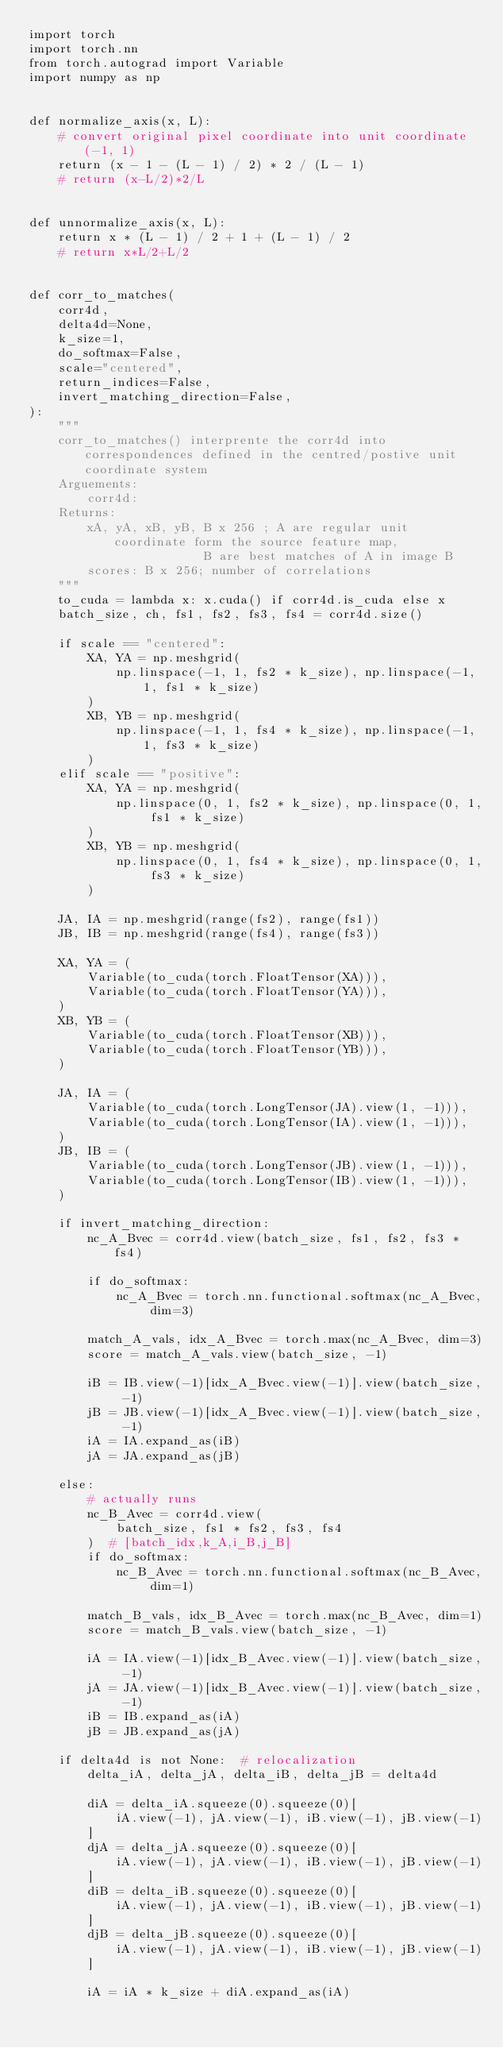Convert code to text. <code><loc_0><loc_0><loc_500><loc_500><_Python_>import torch
import torch.nn
from torch.autograd import Variable
import numpy as np


def normalize_axis(x, L):
    # convert original pixel coordinate into unit coordinate (-1, 1)
    return (x - 1 - (L - 1) / 2) * 2 / (L - 1)
    # return (x-L/2)*2/L


def unnormalize_axis(x, L):
    return x * (L - 1) / 2 + 1 + (L - 1) / 2
    # return x*L/2+L/2


def corr_to_matches(
    corr4d,
    delta4d=None,
    k_size=1,
    do_softmax=False,
    scale="centered",
    return_indices=False,
    invert_matching_direction=False,
):
    """
    corr_to_matches() interprente the corr4d into correspondences defined in the centred/postive unit coordinate system
    Arguements:
        corr4d:
    Returns:
        xA, yA, xB, yB, B x 256 ; A are regular unit coordinate form the source feature map, 
                        B are best matches of A in image B
        scores: B x 256; number of correlations
    """
    to_cuda = lambda x: x.cuda() if corr4d.is_cuda else x
    batch_size, ch, fs1, fs2, fs3, fs4 = corr4d.size()

    if scale == "centered":
        XA, YA = np.meshgrid(
            np.linspace(-1, 1, fs2 * k_size), np.linspace(-1, 1, fs1 * k_size)
        )
        XB, YB = np.meshgrid(
            np.linspace(-1, 1, fs4 * k_size), np.linspace(-1, 1, fs3 * k_size)
        )
    elif scale == "positive":
        XA, YA = np.meshgrid(
            np.linspace(0, 1, fs2 * k_size), np.linspace(0, 1, fs1 * k_size)
        )
        XB, YB = np.meshgrid(
            np.linspace(0, 1, fs4 * k_size), np.linspace(0, 1, fs3 * k_size)
        )

    JA, IA = np.meshgrid(range(fs2), range(fs1))
    JB, IB = np.meshgrid(range(fs4), range(fs3))

    XA, YA = (
        Variable(to_cuda(torch.FloatTensor(XA))),
        Variable(to_cuda(torch.FloatTensor(YA))),
    )
    XB, YB = (
        Variable(to_cuda(torch.FloatTensor(XB))),
        Variable(to_cuda(torch.FloatTensor(YB))),
    )

    JA, IA = (
        Variable(to_cuda(torch.LongTensor(JA).view(1, -1))),
        Variable(to_cuda(torch.LongTensor(IA).view(1, -1))),
    )
    JB, IB = (
        Variable(to_cuda(torch.LongTensor(JB).view(1, -1))),
        Variable(to_cuda(torch.LongTensor(IB).view(1, -1))),
    )

    if invert_matching_direction:
        nc_A_Bvec = corr4d.view(batch_size, fs1, fs2, fs3 * fs4)

        if do_softmax:
            nc_A_Bvec = torch.nn.functional.softmax(nc_A_Bvec, dim=3)

        match_A_vals, idx_A_Bvec = torch.max(nc_A_Bvec, dim=3)
        score = match_A_vals.view(batch_size, -1)

        iB = IB.view(-1)[idx_A_Bvec.view(-1)].view(batch_size, -1)
        jB = JB.view(-1)[idx_A_Bvec.view(-1)].view(batch_size, -1)
        iA = IA.expand_as(iB)
        jA = JA.expand_as(jB)

    else:
        # actually runs
        nc_B_Avec = corr4d.view(
            batch_size, fs1 * fs2, fs3, fs4
        )  # [batch_idx,k_A,i_B,j_B]
        if do_softmax:
            nc_B_Avec = torch.nn.functional.softmax(nc_B_Avec, dim=1)

        match_B_vals, idx_B_Avec = torch.max(nc_B_Avec, dim=1)
        score = match_B_vals.view(batch_size, -1)

        iA = IA.view(-1)[idx_B_Avec.view(-1)].view(batch_size, -1)
        jA = JA.view(-1)[idx_B_Avec.view(-1)].view(batch_size, -1)
        iB = IB.expand_as(iA)
        jB = JB.expand_as(jA)

    if delta4d is not None:  # relocalization
        delta_iA, delta_jA, delta_iB, delta_jB = delta4d

        diA = delta_iA.squeeze(0).squeeze(0)[
            iA.view(-1), jA.view(-1), iB.view(-1), jB.view(-1)
        ]
        djA = delta_jA.squeeze(0).squeeze(0)[
            iA.view(-1), jA.view(-1), iB.view(-1), jB.view(-1)
        ]
        diB = delta_iB.squeeze(0).squeeze(0)[
            iA.view(-1), jA.view(-1), iB.view(-1), jB.view(-1)
        ]
        djB = delta_jB.squeeze(0).squeeze(0)[
            iA.view(-1), jA.view(-1), iB.view(-1), jB.view(-1)
        ]

        iA = iA * k_size + diA.expand_as(iA)</code> 